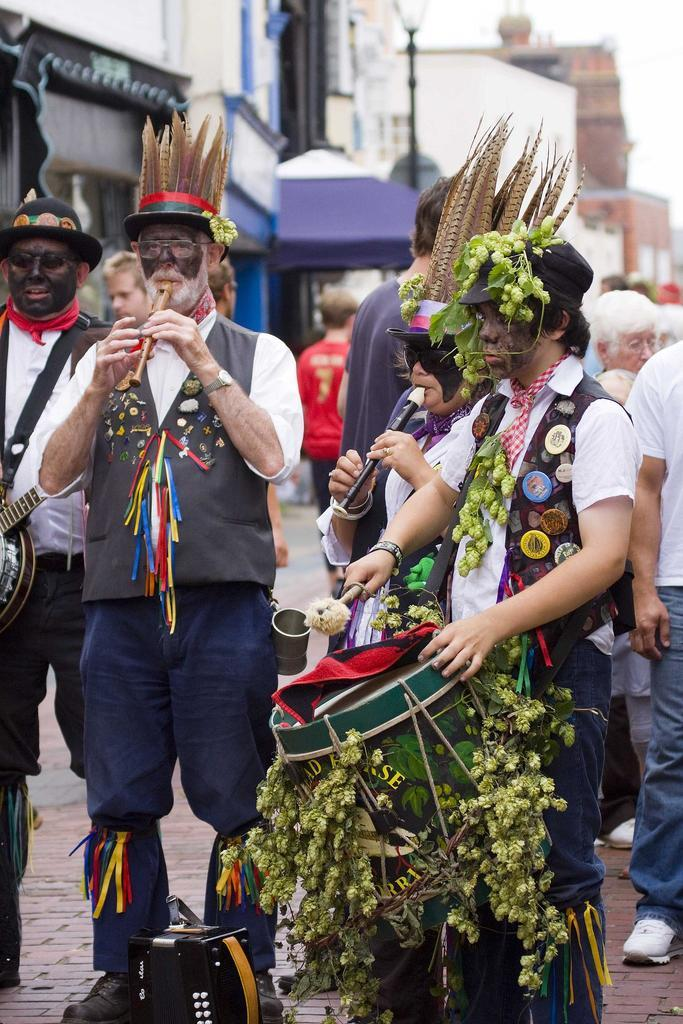What are the people in the image doing? The people in the image are wearing costumes and playing musical instruments. Are there any other people visible in the image? Yes, there are people standing in the background of the image. What can be seen in the distance behind the people? There are buildings visible in the background of the image. How is the background of the image depicted? The background is blurred. What type of advertisement can be seen on the fang of the person in the image? There is no fang or advertisement present in the image. 